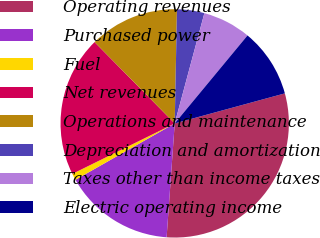Convert chart. <chart><loc_0><loc_0><loc_500><loc_500><pie_chart><fcel>Operating revenues<fcel>Purchased power<fcel>Fuel<fcel>Net revenues<fcel>Operations and maintenance<fcel>Depreciation and amortization<fcel>Taxes other than income taxes<fcel>Electric operating income<nl><fcel>30.37%<fcel>15.65%<fcel>0.93%<fcel>19.91%<fcel>12.7%<fcel>3.87%<fcel>6.82%<fcel>9.76%<nl></chart> 